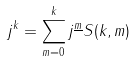Convert formula to latex. <formula><loc_0><loc_0><loc_500><loc_500>j ^ { k } = \sum _ { m = 0 } ^ { k } j ^ { \underline { m } } S ( k , m )</formula> 